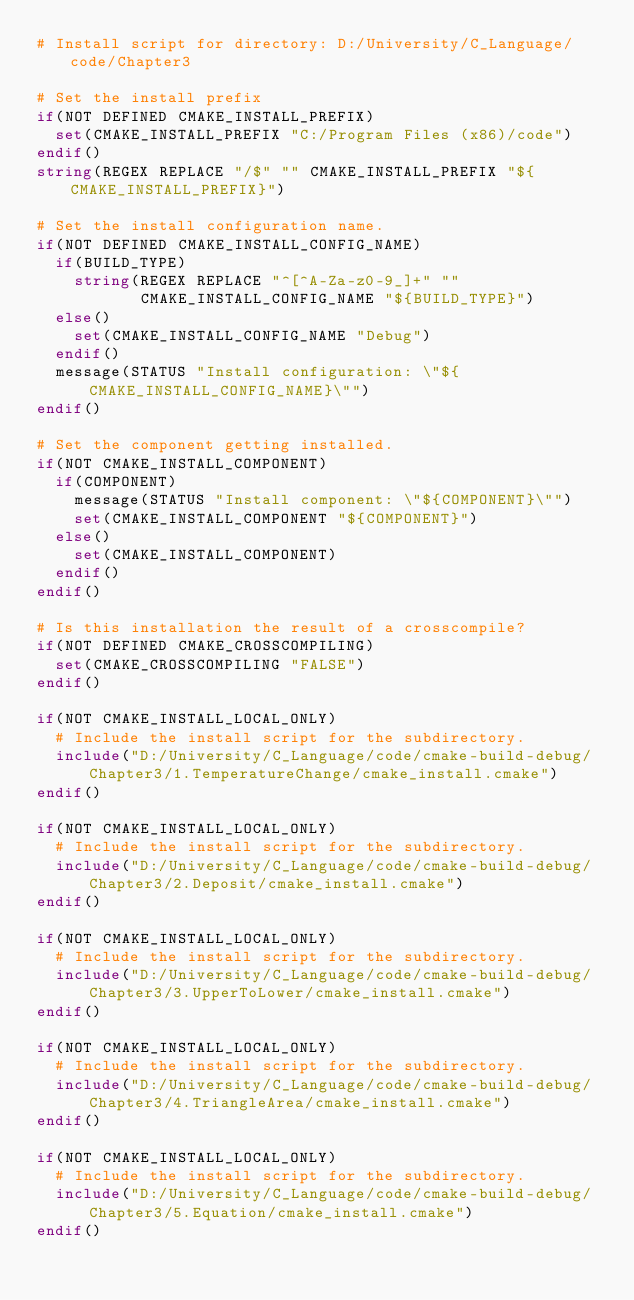<code> <loc_0><loc_0><loc_500><loc_500><_CMake_># Install script for directory: D:/University/C_Language/code/Chapter3

# Set the install prefix
if(NOT DEFINED CMAKE_INSTALL_PREFIX)
  set(CMAKE_INSTALL_PREFIX "C:/Program Files (x86)/code")
endif()
string(REGEX REPLACE "/$" "" CMAKE_INSTALL_PREFIX "${CMAKE_INSTALL_PREFIX}")

# Set the install configuration name.
if(NOT DEFINED CMAKE_INSTALL_CONFIG_NAME)
  if(BUILD_TYPE)
    string(REGEX REPLACE "^[^A-Za-z0-9_]+" ""
           CMAKE_INSTALL_CONFIG_NAME "${BUILD_TYPE}")
  else()
    set(CMAKE_INSTALL_CONFIG_NAME "Debug")
  endif()
  message(STATUS "Install configuration: \"${CMAKE_INSTALL_CONFIG_NAME}\"")
endif()

# Set the component getting installed.
if(NOT CMAKE_INSTALL_COMPONENT)
  if(COMPONENT)
    message(STATUS "Install component: \"${COMPONENT}\"")
    set(CMAKE_INSTALL_COMPONENT "${COMPONENT}")
  else()
    set(CMAKE_INSTALL_COMPONENT)
  endif()
endif()

# Is this installation the result of a crosscompile?
if(NOT DEFINED CMAKE_CROSSCOMPILING)
  set(CMAKE_CROSSCOMPILING "FALSE")
endif()

if(NOT CMAKE_INSTALL_LOCAL_ONLY)
  # Include the install script for the subdirectory.
  include("D:/University/C_Language/code/cmake-build-debug/Chapter3/1.TemperatureChange/cmake_install.cmake")
endif()

if(NOT CMAKE_INSTALL_LOCAL_ONLY)
  # Include the install script for the subdirectory.
  include("D:/University/C_Language/code/cmake-build-debug/Chapter3/2.Deposit/cmake_install.cmake")
endif()

if(NOT CMAKE_INSTALL_LOCAL_ONLY)
  # Include the install script for the subdirectory.
  include("D:/University/C_Language/code/cmake-build-debug/Chapter3/3.UpperToLower/cmake_install.cmake")
endif()

if(NOT CMAKE_INSTALL_LOCAL_ONLY)
  # Include the install script for the subdirectory.
  include("D:/University/C_Language/code/cmake-build-debug/Chapter3/4.TriangleArea/cmake_install.cmake")
endif()

if(NOT CMAKE_INSTALL_LOCAL_ONLY)
  # Include the install script for the subdirectory.
  include("D:/University/C_Language/code/cmake-build-debug/Chapter3/5.Equation/cmake_install.cmake")
endif()

</code> 